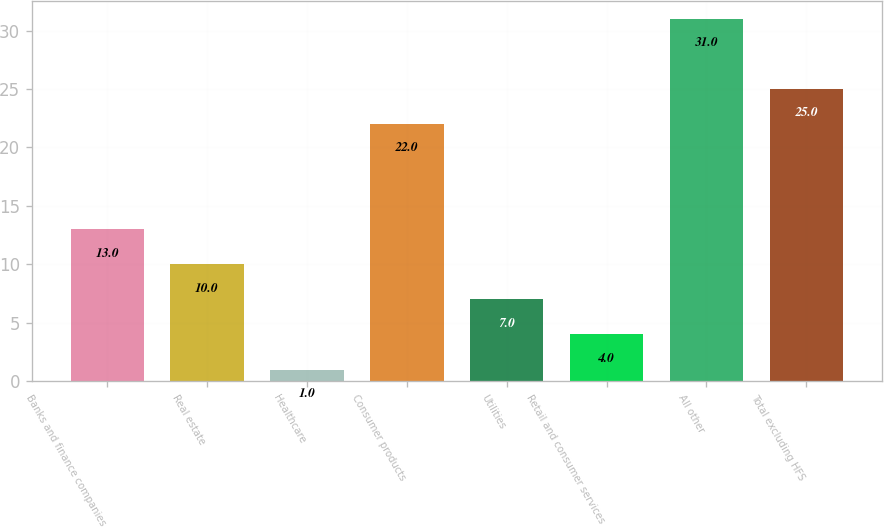Convert chart to OTSL. <chart><loc_0><loc_0><loc_500><loc_500><bar_chart><fcel>Banks and finance companies<fcel>Real estate<fcel>Healthcare<fcel>Consumer products<fcel>Utilities<fcel>Retail and consumer services<fcel>All other<fcel>Total excluding HFS<nl><fcel>13<fcel>10<fcel>1<fcel>22<fcel>7<fcel>4<fcel>31<fcel>25<nl></chart> 